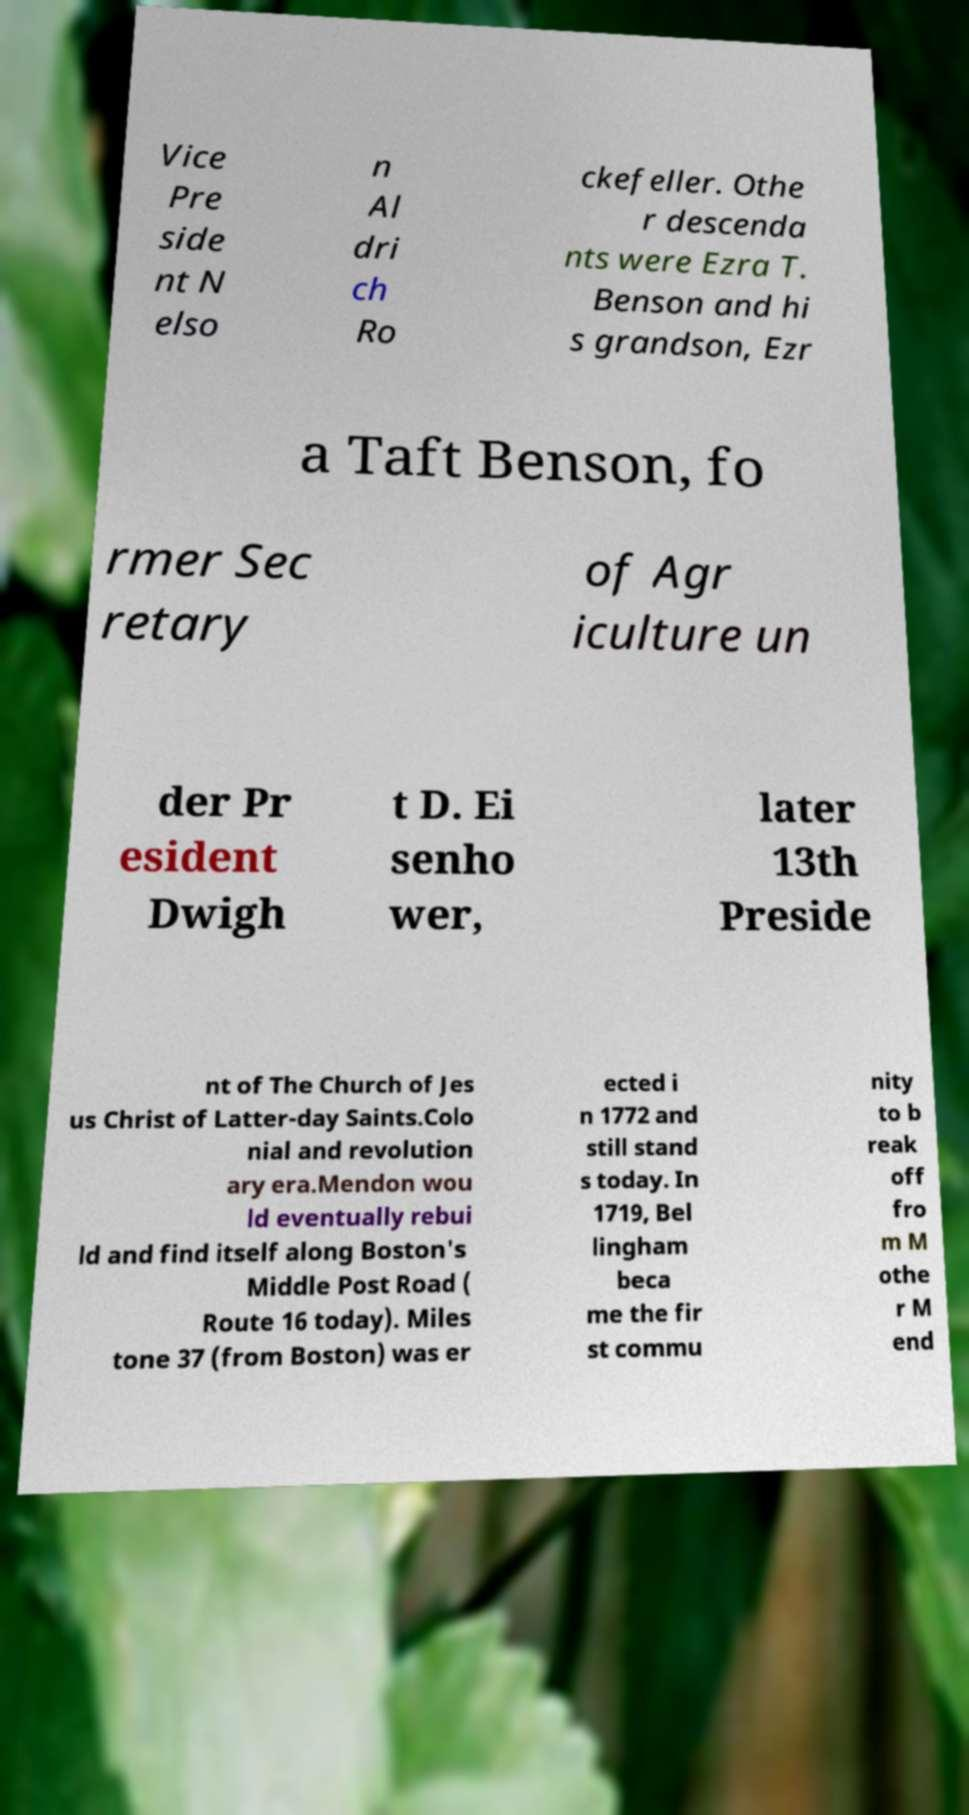Can you accurately transcribe the text from the provided image for me? Vice Pre side nt N elso n Al dri ch Ro ckefeller. Othe r descenda nts were Ezra T. Benson and hi s grandson, Ezr a Taft Benson, fo rmer Sec retary of Agr iculture un der Pr esident Dwigh t D. Ei senho wer, later 13th Preside nt of The Church of Jes us Christ of Latter-day Saints.Colo nial and revolution ary era.Mendon wou ld eventually rebui ld and find itself along Boston's Middle Post Road ( Route 16 today). Miles tone 37 (from Boston) was er ected i n 1772 and still stand s today. In 1719, Bel lingham beca me the fir st commu nity to b reak off fro m M othe r M end 